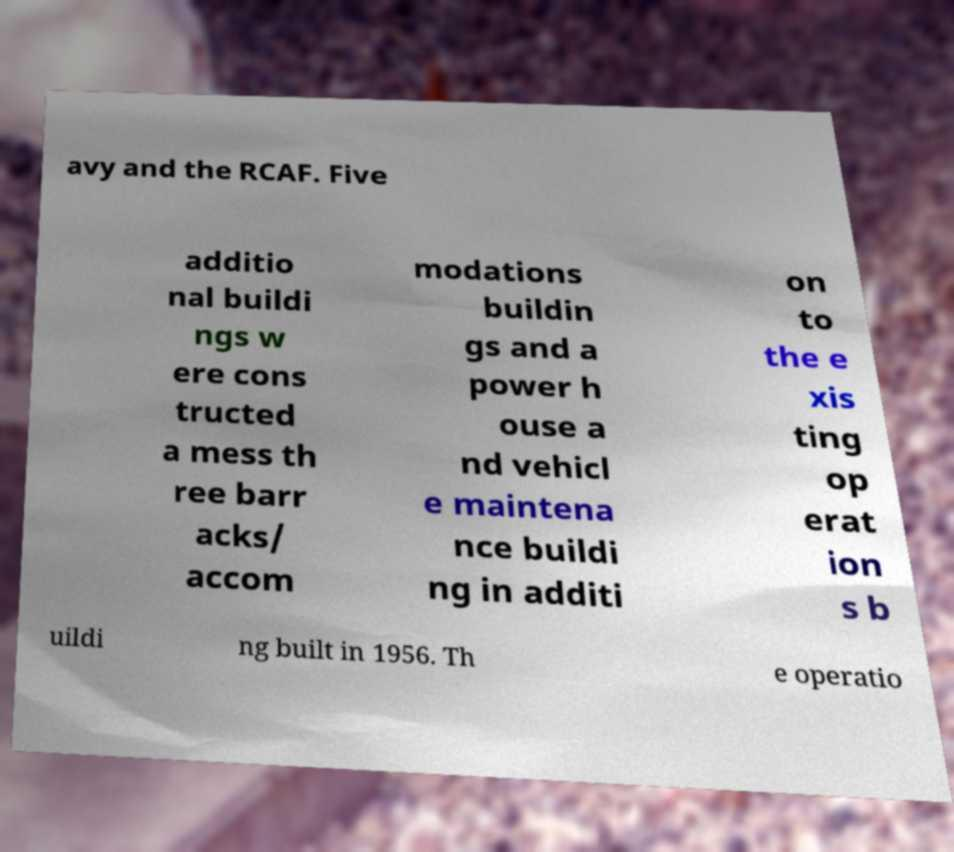Can you read and provide the text displayed in the image?This photo seems to have some interesting text. Can you extract and type it out for me? avy and the RCAF. Five additio nal buildi ngs w ere cons tructed a mess th ree barr acks/ accom modations buildin gs and a power h ouse a nd vehicl e maintena nce buildi ng in additi on to the e xis ting op erat ion s b uildi ng built in 1956. Th e operatio 